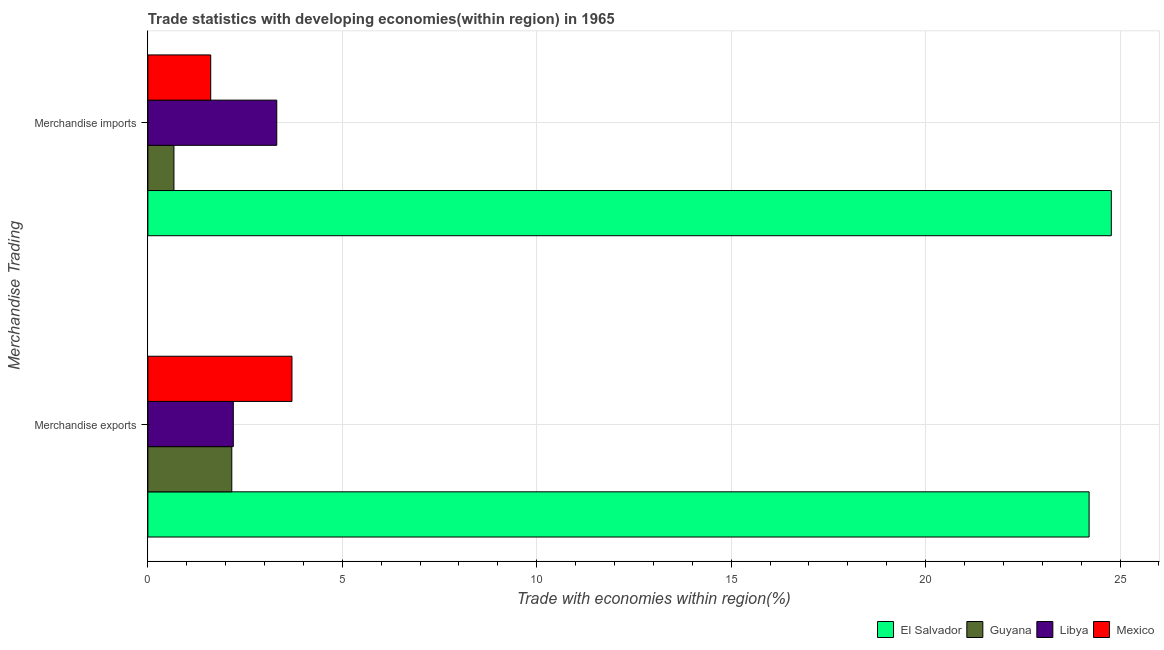How many different coloured bars are there?
Offer a terse response. 4. How many bars are there on the 2nd tick from the top?
Your answer should be compact. 4. What is the label of the 1st group of bars from the top?
Offer a terse response. Merchandise imports. What is the merchandise exports in Mexico?
Offer a very short reply. 3.71. Across all countries, what is the maximum merchandise exports?
Keep it short and to the point. 24.2. Across all countries, what is the minimum merchandise exports?
Provide a short and direct response. 2.16. In which country was the merchandise exports maximum?
Make the answer very short. El Salvador. In which country was the merchandise imports minimum?
Offer a terse response. Guyana. What is the total merchandise exports in the graph?
Provide a short and direct response. 32.26. What is the difference between the merchandise imports in Guyana and that in El Salvador?
Ensure brevity in your answer.  -24.1. What is the difference between the merchandise exports in El Salvador and the merchandise imports in Libya?
Offer a very short reply. 20.89. What is the average merchandise imports per country?
Your answer should be compact. 7.59. What is the difference between the merchandise imports and merchandise exports in El Salvador?
Make the answer very short. 0.57. What is the ratio of the merchandise imports in El Salvador to that in Guyana?
Keep it short and to the point. 36.95. In how many countries, is the merchandise exports greater than the average merchandise exports taken over all countries?
Give a very brief answer. 1. What does the 4th bar from the top in Merchandise imports represents?
Provide a succinct answer. El Salvador. What does the 4th bar from the bottom in Merchandise imports represents?
Your answer should be compact. Mexico. What is the difference between two consecutive major ticks on the X-axis?
Keep it short and to the point. 5. Where does the legend appear in the graph?
Make the answer very short. Bottom right. What is the title of the graph?
Give a very brief answer. Trade statistics with developing economies(within region) in 1965. What is the label or title of the X-axis?
Your response must be concise. Trade with economies within region(%). What is the label or title of the Y-axis?
Keep it short and to the point. Merchandise Trading. What is the Trade with economies within region(%) in El Salvador in Merchandise exports?
Provide a succinct answer. 24.2. What is the Trade with economies within region(%) of Guyana in Merchandise exports?
Offer a very short reply. 2.16. What is the Trade with economies within region(%) in Libya in Merchandise exports?
Offer a very short reply. 2.2. What is the Trade with economies within region(%) in Mexico in Merchandise exports?
Offer a terse response. 3.71. What is the Trade with economies within region(%) in El Salvador in Merchandise imports?
Provide a short and direct response. 24.77. What is the Trade with economies within region(%) of Guyana in Merchandise imports?
Your response must be concise. 0.67. What is the Trade with economies within region(%) in Libya in Merchandise imports?
Your answer should be compact. 3.31. What is the Trade with economies within region(%) of Mexico in Merchandise imports?
Offer a terse response. 1.62. Across all Merchandise Trading, what is the maximum Trade with economies within region(%) of El Salvador?
Give a very brief answer. 24.77. Across all Merchandise Trading, what is the maximum Trade with economies within region(%) in Guyana?
Provide a short and direct response. 2.16. Across all Merchandise Trading, what is the maximum Trade with economies within region(%) in Libya?
Your response must be concise. 3.31. Across all Merchandise Trading, what is the maximum Trade with economies within region(%) in Mexico?
Offer a very short reply. 3.71. Across all Merchandise Trading, what is the minimum Trade with economies within region(%) in El Salvador?
Provide a succinct answer. 24.2. Across all Merchandise Trading, what is the minimum Trade with economies within region(%) of Guyana?
Offer a terse response. 0.67. Across all Merchandise Trading, what is the minimum Trade with economies within region(%) in Libya?
Give a very brief answer. 2.2. Across all Merchandise Trading, what is the minimum Trade with economies within region(%) in Mexico?
Make the answer very short. 1.62. What is the total Trade with economies within region(%) of El Salvador in the graph?
Your response must be concise. 48.98. What is the total Trade with economies within region(%) in Guyana in the graph?
Keep it short and to the point. 2.83. What is the total Trade with economies within region(%) in Libya in the graph?
Your answer should be very brief. 5.51. What is the total Trade with economies within region(%) in Mexico in the graph?
Ensure brevity in your answer.  5.32. What is the difference between the Trade with economies within region(%) of El Salvador in Merchandise exports and that in Merchandise imports?
Your answer should be very brief. -0.57. What is the difference between the Trade with economies within region(%) in Guyana in Merchandise exports and that in Merchandise imports?
Offer a terse response. 1.49. What is the difference between the Trade with economies within region(%) of Libya in Merchandise exports and that in Merchandise imports?
Ensure brevity in your answer.  -1.12. What is the difference between the Trade with economies within region(%) in Mexico in Merchandise exports and that in Merchandise imports?
Give a very brief answer. 2.09. What is the difference between the Trade with economies within region(%) in El Salvador in Merchandise exports and the Trade with economies within region(%) in Guyana in Merchandise imports?
Ensure brevity in your answer.  23.53. What is the difference between the Trade with economies within region(%) of El Salvador in Merchandise exports and the Trade with economies within region(%) of Libya in Merchandise imports?
Your response must be concise. 20.89. What is the difference between the Trade with economies within region(%) of El Salvador in Merchandise exports and the Trade with economies within region(%) of Mexico in Merchandise imports?
Keep it short and to the point. 22.59. What is the difference between the Trade with economies within region(%) in Guyana in Merchandise exports and the Trade with economies within region(%) in Libya in Merchandise imports?
Provide a succinct answer. -1.16. What is the difference between the Trade with economies within region(%) in Guyana in Merchandise exports and the Trade with economies within region(%) in Mexico in Merchandise imports?
Your response must be concise. 0.54. What is the difference between the Trade with economies within region(%) in Libya in Merchandise exports and the Trade with economies within region(%) in Mexico in Merchandise imports?
Your response must be concise. 0.58. What is the average Trade with economies within region(%) in El Salvador per Merchandise Trading?
Make the answer very short. 24.49. What is the average Trade with economies within region(%) of Guyana per Merchandise Trading?
Offer a very short reply. 1.41. What is the average Trade with economies within region(%) in Libya per Merchandise Trading?
Provide a succinct answer. 2.76. What is the average Trade with economies within region(%) of Mexico per Merchandise Trading?
Give a very brief answer. 2.66. What is the difference between the Trade with economies within region(%) of El Salvador and Trade with economies within region(%) of Guyana in Merchandise exports?
Ensure brevity in your answer.  22.05. What is the difference between the Trade with economies within region(%) of El Salvador and Trade with economies within region(%) of Libya in Merchandise exports?
Your answer should be very brief. 22.01. What is the difference between the Trade with economies within region(%) in El Salvador and Trade with economies within region(%) in Mexico in Merchandise exports?
Ensure brevity in your answer.  20.5. What is the difference between the Trade with economies within region(%) of Guyana and Trade with economies within region(%) of Libya in Merchandise exports?
Give a very brief answer. -0.04. What is the difference between the Trade with economies within region(%) of Guyana and Trade with economies within region(%) of Mexico in Merchandise exports?
Keep it short and to the point. -1.55. What is the difference between the Trade with economies within region(%) in Libya and Trade with economies within region(%) in Mexico in Merchandise exports?
Your response must be concise. -1.51. What is the difference between the Trade with economies within region(%) in El Salvador and Trade with economies within region(%) in Guyana in Merchandise imports?
Your answer should be compact. 24.1. What is the difference between the Trade with economies within region(%) in El Salvador and Trade with economies within region(%) in Libya in Merchandise imports?
Make the answer very short. 21.46. What is the difference between the Trade with economies within region(%) in El Salvador and Trade with economies within region(%) in Mexico in Merchandise imports?
Ensure brevity in your answer.  23.16. What is the difference between the Trade with economies within region(%) of Guyana and Trade with economies within region(%) of Libya in Merchandise imports?
Provide a short and direct response. -2.64. What is the difference between the Trade with economies within region(%) in Guyana and Trade with economies within region(%) in Mexico in Merchandise imports?
Keep it short and to the point. -0.95. What is the difference between the Trade with economies within region(%) in Libya and Trade with economies within region(%) in Mexico in Merchandise imports?
Keep it short and to the point. 1.7. What is the ratio of the Trade with economies within region(%) in Guyana in Merchandise exports to that in Merchandise imports?
Give a very brief answer. 3.22. What is the ratio of the Trade with economies within region(%) in Libya in Merchandise exports to that in Merchandise imports?
Provide a succinct answer. 0.66. What is the ratio of the Trade with economies within region(%) of Mexico in Merchandise exports to that in Merchandise imports?
Ensure brevity in your answer.  2.29. What is the difference between the highest and the second highest Trade with economies within region(%) in El Salvador?
Your response must be concise. 0.57. What is the difference between the highest and the second highest Trade with economies within region(%) in Guyana?
Make the answer very short. 1.49. What is the difference between the highest and the second highest Trade with economies within region(%) of Libya?
Your answer should be compact. 1.12. What is the difference between the highest and the second highest Trade with economies within region(%) in Mexico?
Offer a terse response. 2.09. What is the difference between the highest and the lowest Trade with economies within region(%) in El Salvador?
Ensure brevity in your answer.  0.57. What is the difference between the highest and the lowest Trade with economies within region(%) in Guyana?
Your response must be concise. 1.49. What is the difference between the highest and the lowest Trade with economies within region(%) in Libya?
Provide a succinct answer. 1.12. What is the difference between the highest and the lowest Trade with economies within region(%) in Mexico?
Give a very brief answer. 2.09. 